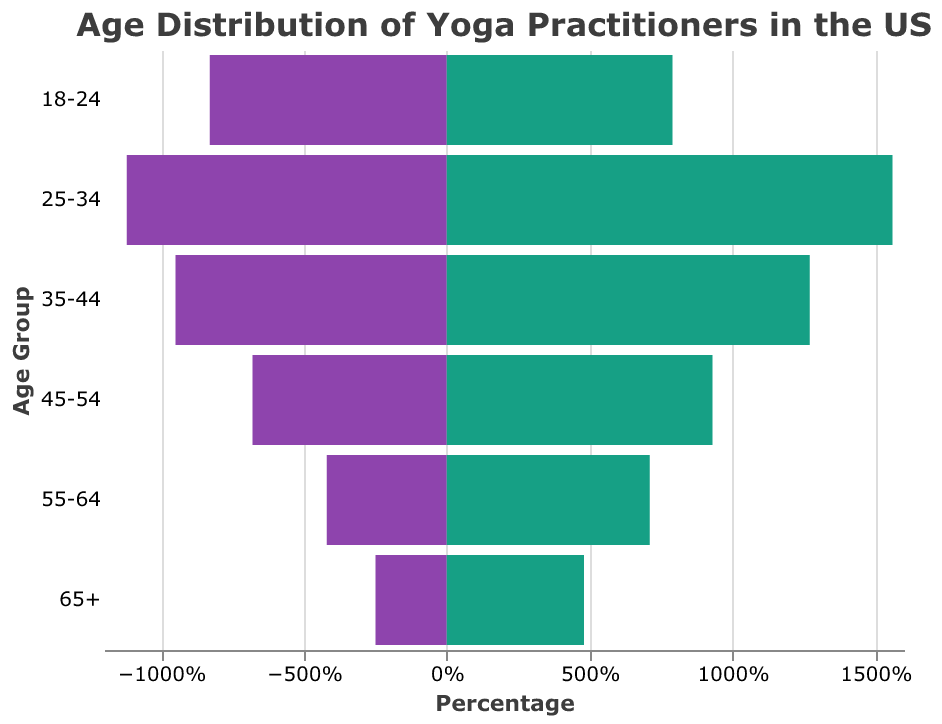What is the title of the figure? The title of the figure is displayed at the top center. It reads, "Age Distribution of Yoga Practitioners in the US."
Answer: Age Distribution of Yoga Practitioners in the US How many age groups are represented in the figure? The figure shows different bars for each age group, and there are a total of six age groups listed on the y-axis.
Answer: Six Which age group has the highest percentage of yoga practitioners without dogs? By examining the length of the bars on the right side (green color), the age group with the highest percentage is "25-34" with 15.6%.
Answer: 25-34 Which age group has a higher percentage of practitioners with dogs compared to without dogs? Comparing the purple and green bars, the "18-24" age group has a higher percentage with dogs (8.3%) than without dogs (7.9%).
Answer: 18-24 For the age group "55-64", how much lower is the percentage of yoga practitioners with dogs compared to those without dogs? For "55-64," the percentage with dogs is 4.2%, and the percentage without dogs is 7.1%. The difference is 7.1% - 4.2% = 2.9%.
Answer: 2.9% What is the combined percentage of yoga practitioners with dogs in the age groups "25-34" and "35-44"? Adding the percentages, "25-34" with dogs is 11.2%, and "35-44" with dogs is 9.5%. Combined, it is 11.2% + 9.5% = 20.7%.
Answer: 20.7% Compare the total percentages of yoga practitioners with dogs and without dogs for the age groups "45-54" and "55-64". Which total is higher and by how much? Summing the percentages for "45-54" and "55-64": With dogs: 6.8% + 4.2% = 11%. Without dogs: 9.3% + 7.1% = 16.4%. The total percentage without dogs is higher by 16.4% - 11% = 5.4%.
Answer: Without dogs by 5.4% Identify the age group with the smallest difference in the percentage of yoga practitioners with and without dogs. What is the difference? Subtract the percentages for each age group and find the smallest difference: "65+" (4.8% - 2.5% = 2.3%), "55-64" (7.1% - 4.2% = 2.9%), "45-54" (9.3% - 6.8% = 2.5%), "35-44" (12.7% - 9.5% = 3.2%), "25-34" (15.6% - 11.2% = 4.4%), "18-24" (8.3% - 7.9% = 0.4%). The "18-24" age group has the smallest difference of 0.4%.
Answer: 18-24, 0.4% What can be inferred about the age group "35-44" in terms of yoga practice with and without dogs? "35-44" has a higher percentage of practitioners without dogs (12.7%) compared to with dogs (9.5%). This suggests that people in this age group are more likely to practice yoga without their dogs.
Answer: More likely to practice without dogs 